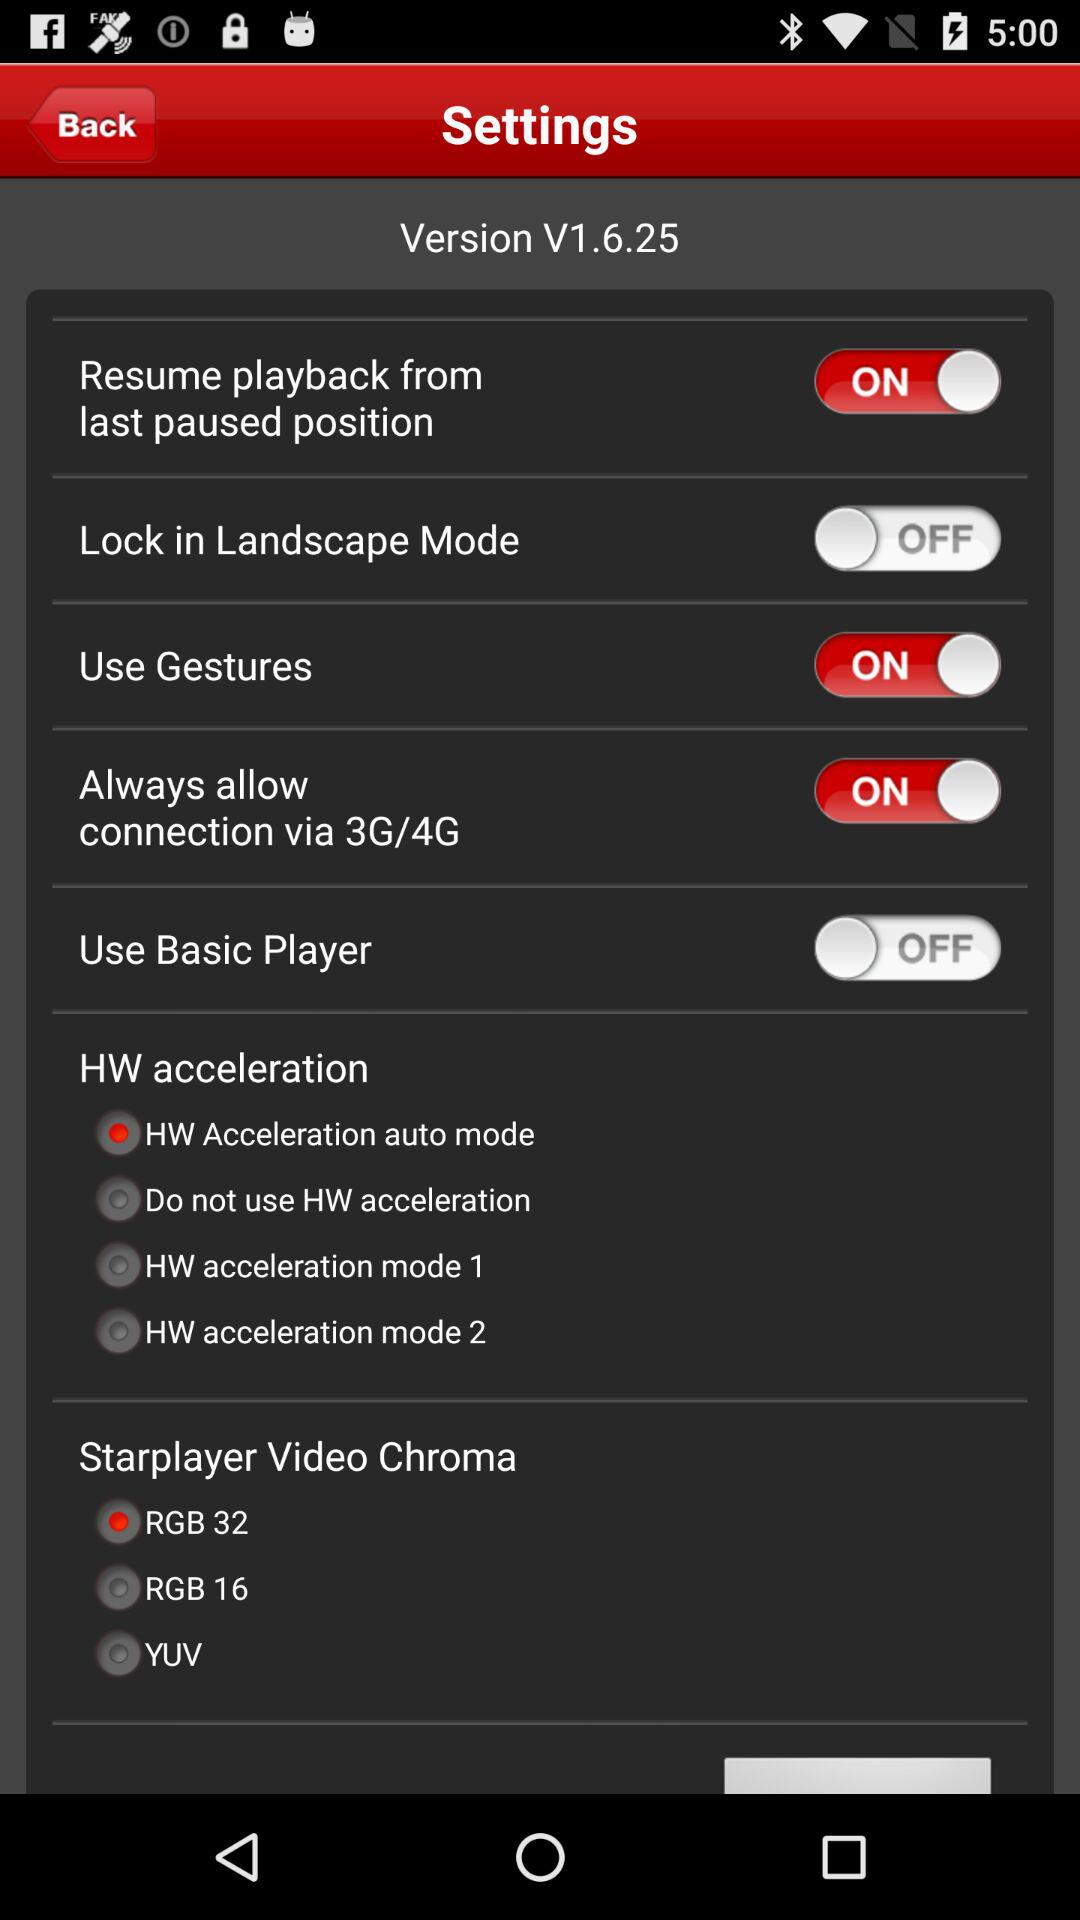What is the status of "Use Gestures"? The status of "Use Gestures" is "on". 